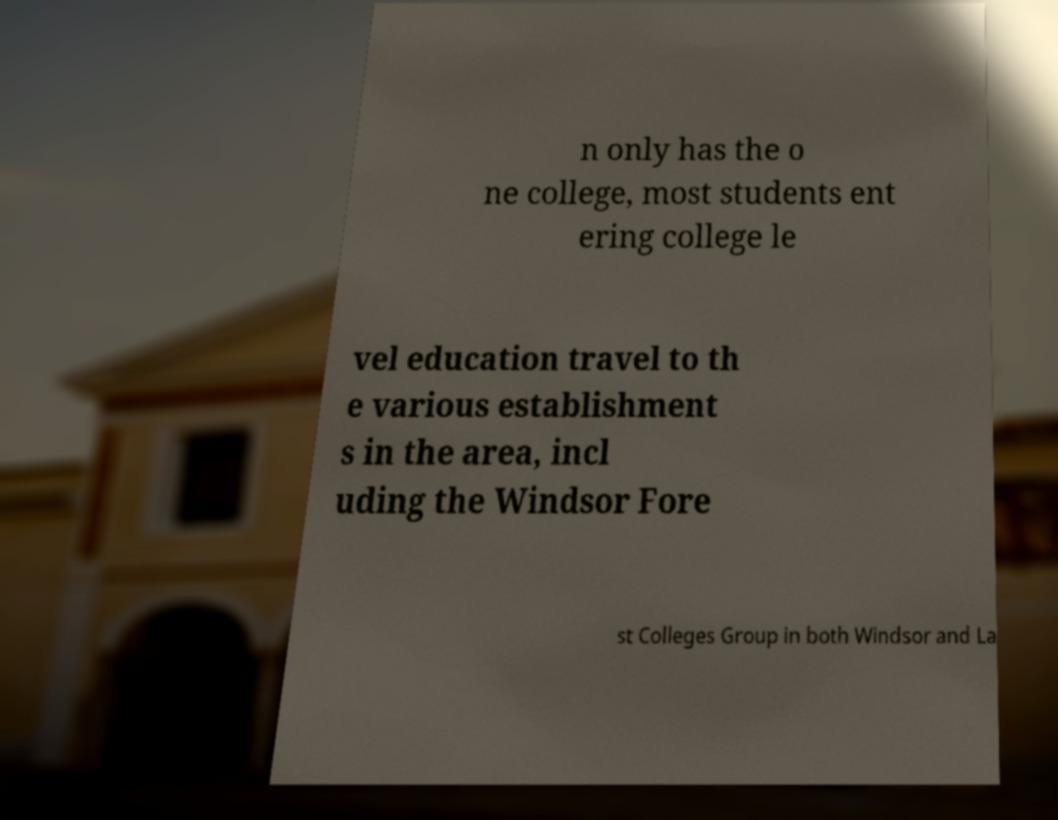Please identify and transcribe the text found in this image. n only has the o ne college, most students ent ering college le vel education travel to th e various establishment s in the area, incl uding the Windsor Fore st Colleges Group in both Windsor and La 